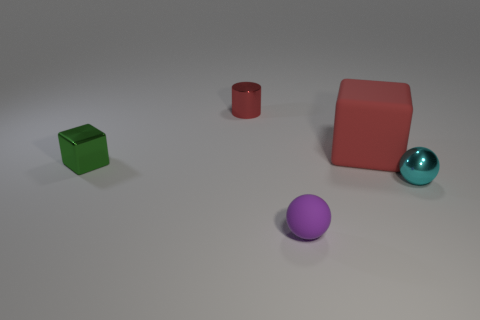There is a cube in front of the red cube; what is its material?
Offer a very short reply. Metal. There is a small metal object that is the same shape as the large red object; what color is it?
Offer a terse response. Green. How many tiny objects have the same color as the large rubber object?
Your response must be concise. 1. There is a ball right of the small purple sphere; is it the same size as the red thing to the right of the red metallic object?
Keep it short and to the point. No. Is the size of the cyan object the same as the red thing left of the tiny purple rubber object?
Provide a short and direct response. Yes. What size is the cyan thing?
Your answer should be compact. Small. There is a cube that is the same material as the tiny cylinder; what is its color?
Provide a succinct answer. Green. What number of cyan things have the same material as the big red block?
Your answer should be very brief. 0. How many objects are either yellow metallic balls or things that are to the left of the tiny shiny cylinder?
Your answer should be very brief. 1. Is the block right of the metallic cylinder made of the same material as the tiny green object?
Your answer should be compact. No. 